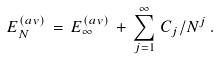Convert formula to latex. <formula><loc_0><loc_0><loc_500><loc_500>E _ { N } ^ { ( a v ) } \, = \, E _ { \infty } ^ { ( a v ) } \, + \, \sum _ { j = 1 } ^ { \infty } \, C _ { j } / N ^ { j } \, .</formula> 